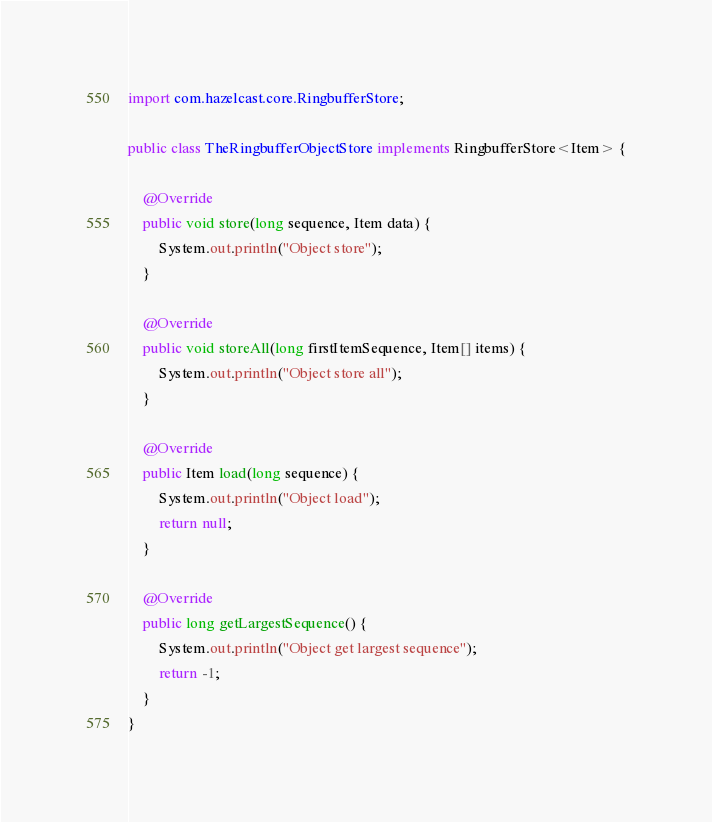Convert code to text. <code><loc_0><loc_0><loc_500><loc_500><_Java_>import com.hazelcast.core.RingbufferStore;

public class TheRingbufferObjectStore implements RingbufferStore<Item> {

    @Override
    public void store(long sequence, Item data) {
        System.out.println("Object store");
    }

    @Override
    public void storeAll(long firstItemSequence, Item[] items) {
        System.out.println("Object store all");
    }

    @Override
    public Item load(long sequence) {
        System.out.println("Object load");
        return null;
    }

    @Override
    public long getLargestSequence() {
        System.out.println("Object get largest sequence");
        return -1;
    }
}
</code> 